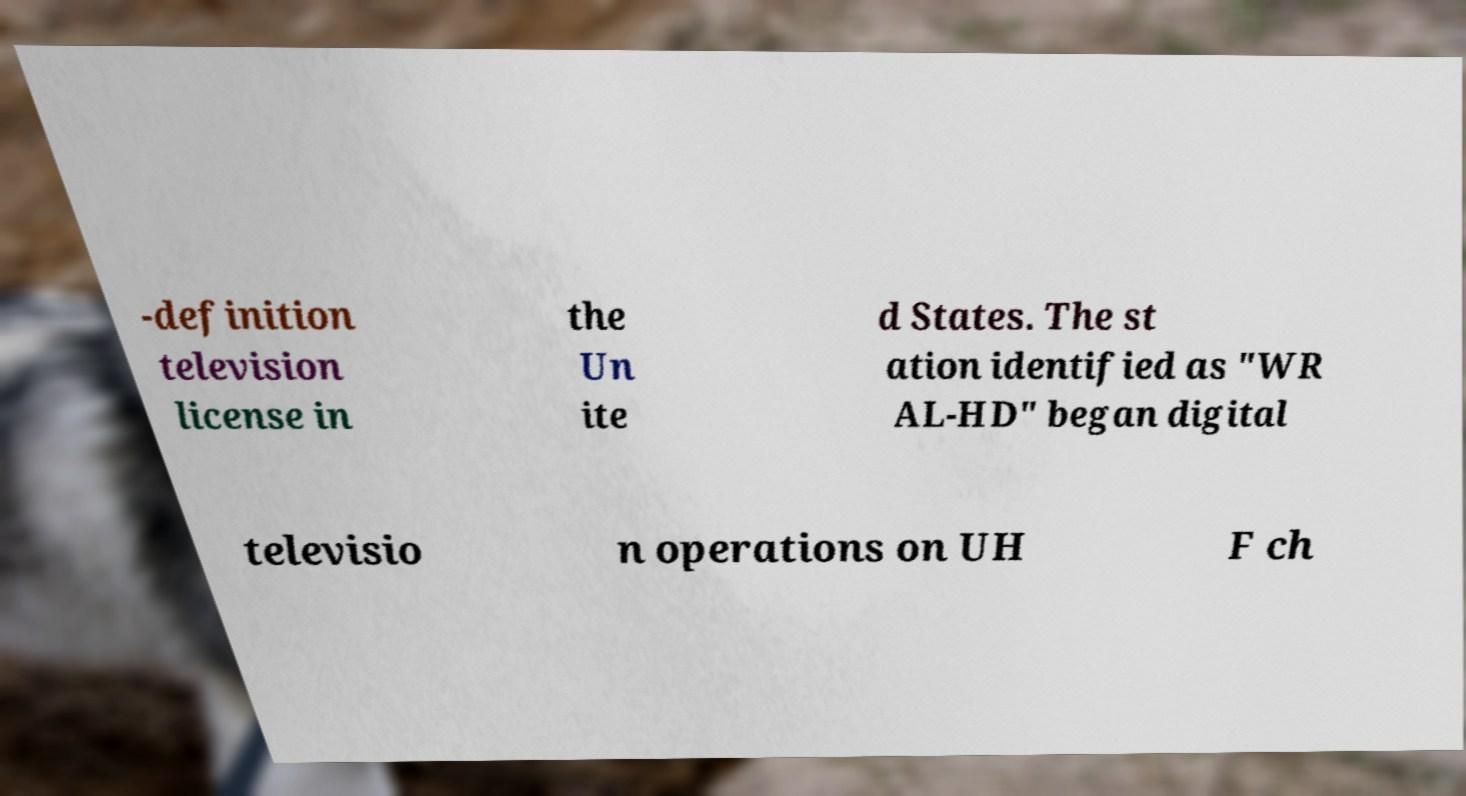Please read and relay the text visible in this image. What does it say? -definition television license in the Un ite d States. The st ation identified as "WR AL-HD" began digital televisio n operations on UH F ch 